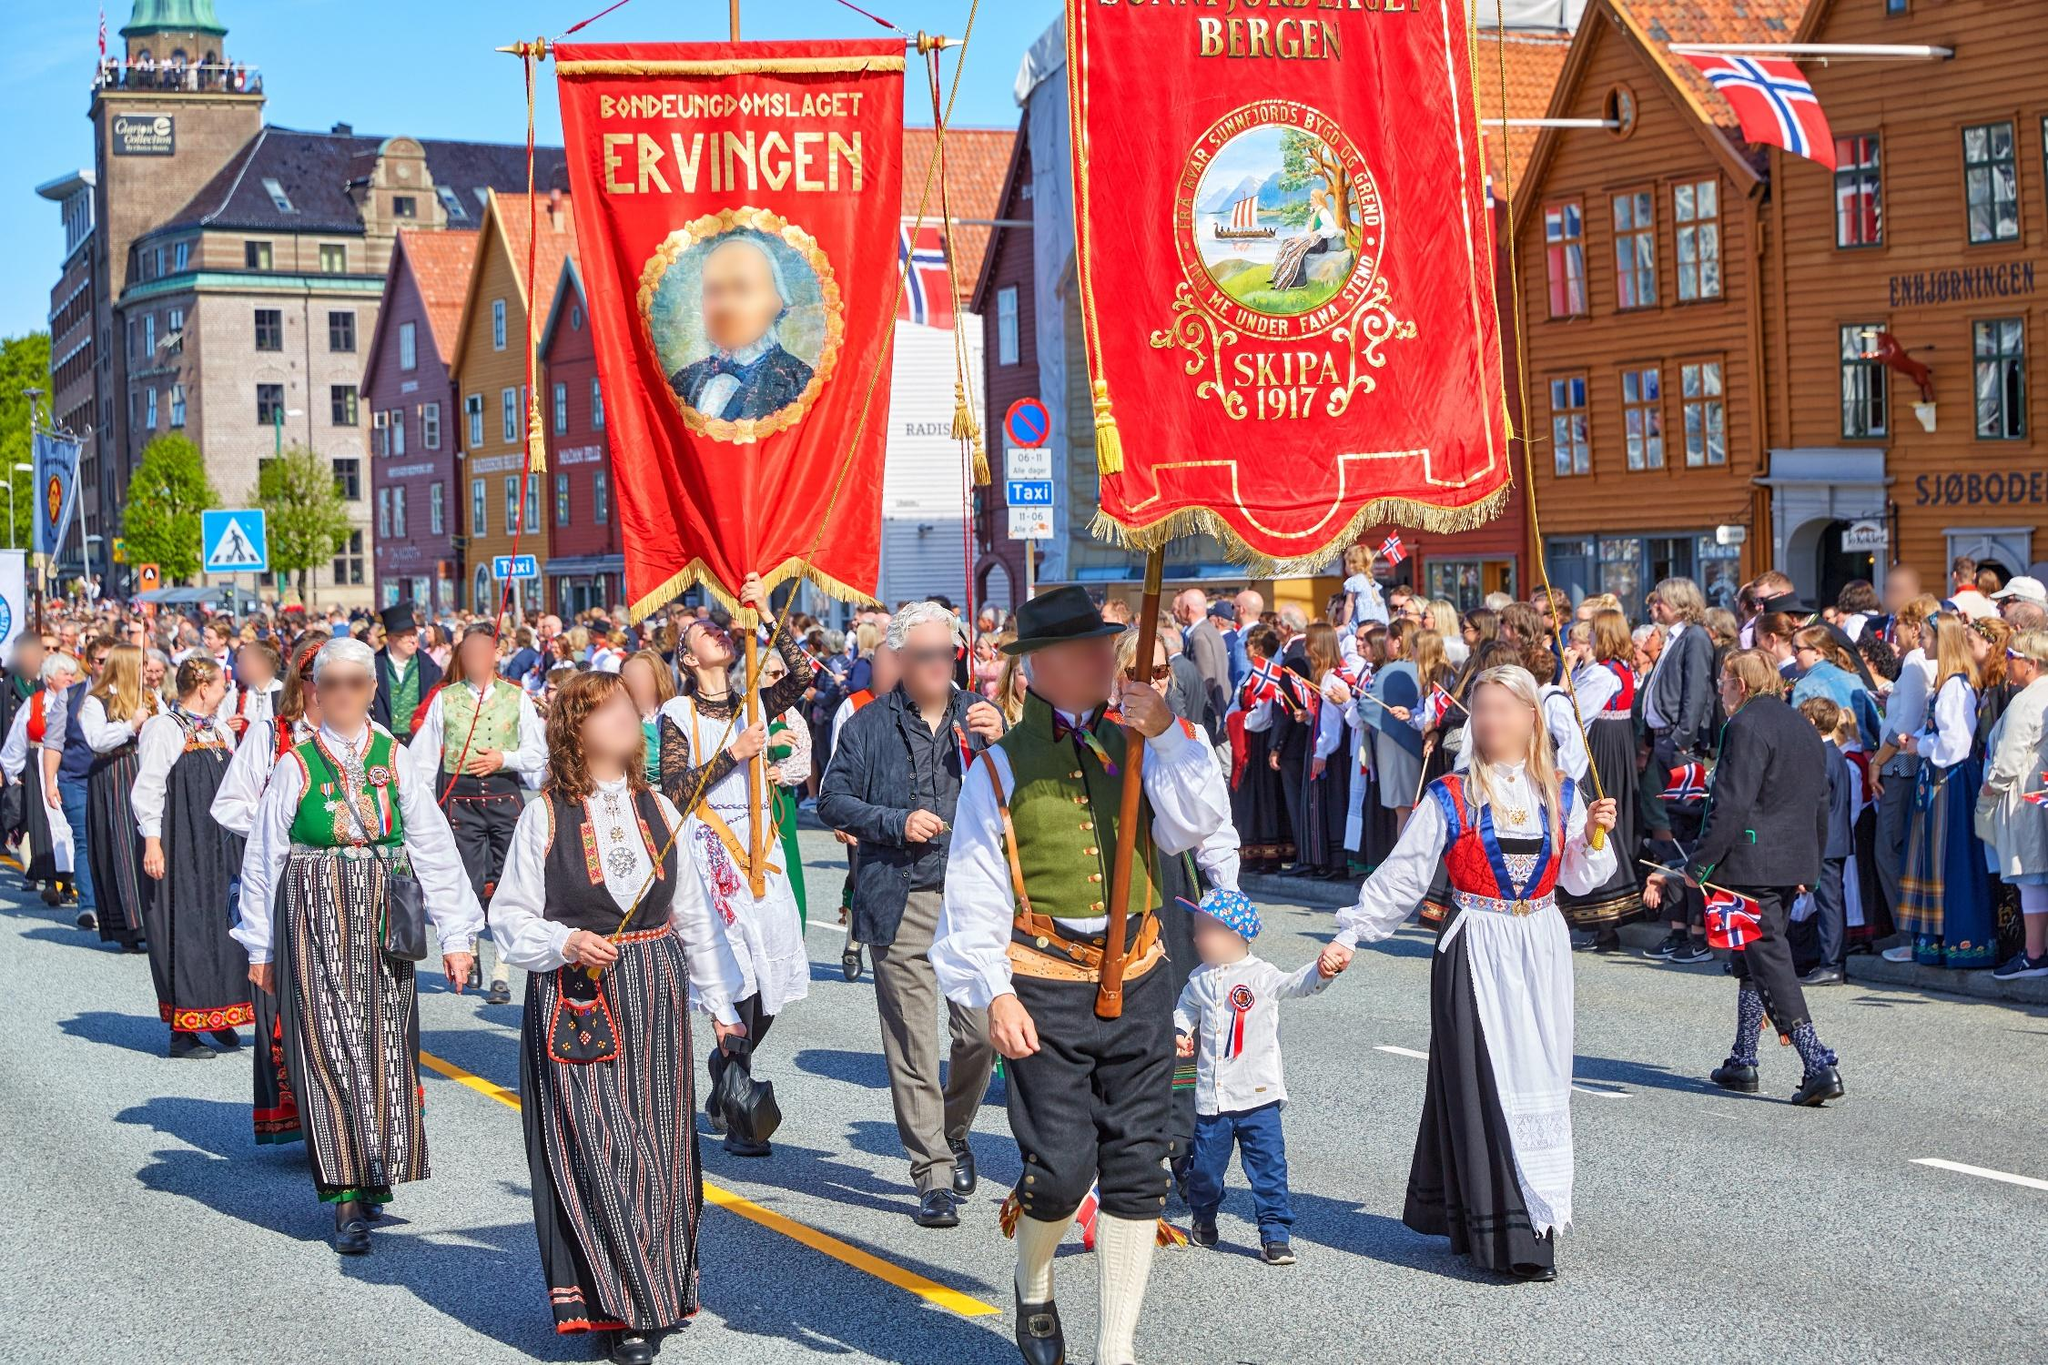Describe a scenario where this image takes place in a world filled with mythical creatures. In a fantastical world brimming with mythical creatures, the parade in Bergen is even more enchanting. Dragons with iridescent scales glide silently above the streets, casting shimmering shadows on the onlookers. Elves dressed in ethereal, glowing bunads march gracefully, their pointed ears twitching in response to the joyous cheers from the crowd. Among the humans, you can spot some dwarves, their sturdy forms clad in rich, earth-toned fabrics, and their beards braided with intricate silver threads. Centaurs trotting alongside humans add to the diversity of the parade. Colorful sprites flit around the banners, their tiny wings leaving trails of glitter in the air. Despite the fantastical elements, the sense of community and celebration remains at the heart of this magical parade. 